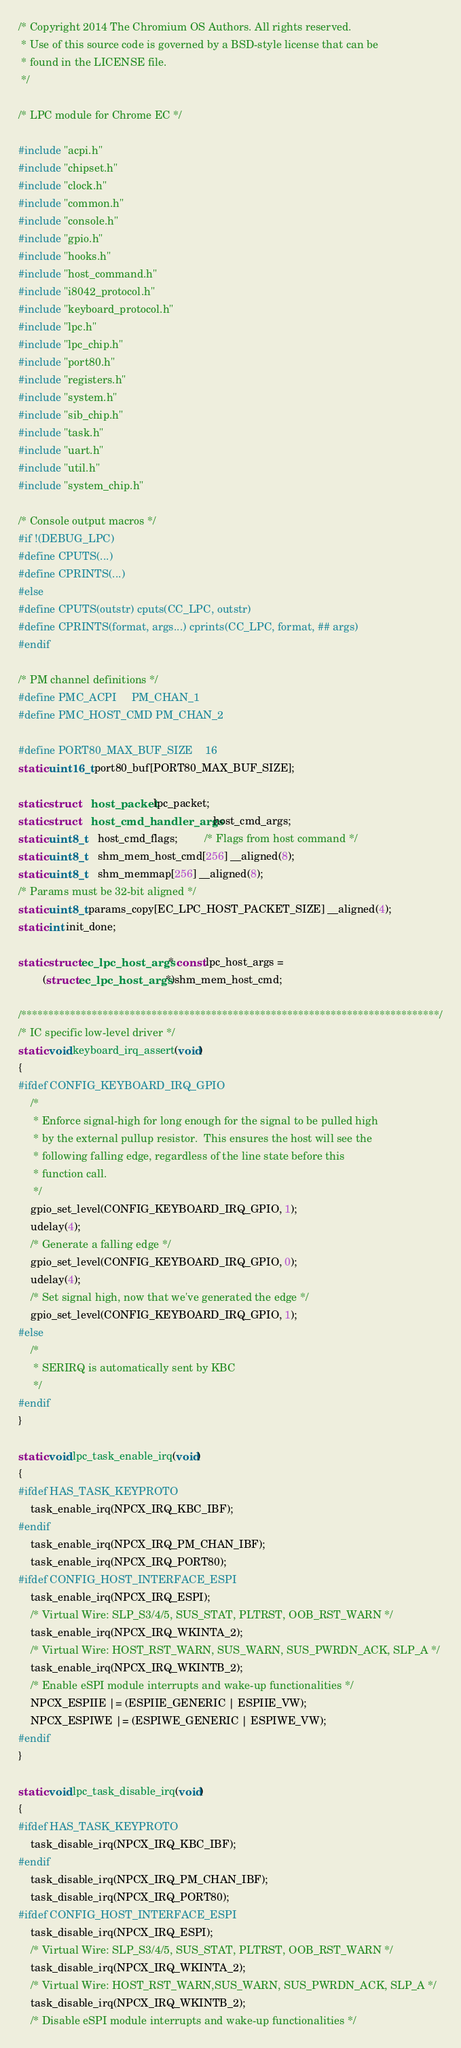Convert code to text. <code><loc_0><loc_0><loc_500><loc_500><_C_>/* Copyright 2014 The Chromium OS Authors. All rights reserved.
 * Use of this source code is governed by a BSD-style license that can be
 * found in the LICENSE file.
 */

/* LPC module for Chrome EC */

#include "acpi.h"
#include "chipset.h"
#include "clock.h"
#include "common.h"
#include "console.h"
#include "gpio.h"
#include "hooks.h"
#include "host_command.h"
#include "i8042_protocol.h"
#include "keyboard_protocol.h"
#include "lpc.h"
#include "lpc_chip.h"
#include "port80.h"
#include "registers.h"
#include "system.h"
#include "sib_chip.h"
#include "task.h"
#include "uart.h"
#include "util.h"
#include "system_chip.h"

/* Console output macros */
#if !(DEBUG_LPC)
#define CPUTS(...)
#define CPRINTS(...)
#else
#define CPUTS(outstr) cputs(CC_LPC, outstr)
#define CPRINTS(format, args...) cprints(CC_LPC, format, ## args)
#endif

/* PM channel definitions */
#define PMC_ACPI     PM_CHAN_1
#define PMC_HOST_CMD PM_CHAN_2

#define PORT80_MAX_BUF_SIZE    16
static uint16_t port80_buf[PORT80_MAX_BUF_SIZE];

static struct	host_packet lpc_packet;
static struct	host_cmd_handler_args host_cmd_args;
static uint8_t	host_cmd_flags;         /* Flags from host command */
static uint8_t	shm_mem_host_cmd[256] __aligned(8);
static uint8_t	shm_memmap[256] __aligned(8);
/* Params must be 32-bit aligned */
static uint8_t params_copy[EC_LPC_HOST_PACKET_SIZE] __aligned(4);
static int init_done;

static struct ec_lpc_host_args * const lpc_host_args =
		(struct ec_lpc_host_args *)shm_mem_host_cmd;

/*****************************************************************************/
/* IC specific low-level driver */
static void keyboard_irq_assert(void)
{
#ifdef CONFIG_KEYBOARD_IRQ_GPIO
	/*
	 * Enforce signal-high for long enough for the signal to be pulled high
	 * by the external pullup resistor.  This ensures the host will see the
	 * following falling edge, regardless of the line state before this
	 * function call.
	 */
	gpio_set_level(CONFIG_KEYBOARD_IRQ_GPIO, 1);
	udelay(4);
	/* Generate a falling edge */
	gpio_set_level(CONFIG_KEYBOARD_IRQ_GPIO, 0);
	udelay(4);
	/* Set signal high, now that we've generated the edge */
	gpio_set_level(CONFIG_KEYBOARD_IRQ_GPIO, 1);
#else
	/*
	 * SERIRQ is automatically sent by KBC
	 */
#endif
}

static void lpc_task_enable_irq(void)
{
#ifdef HAS_TASK_KEYPROTO
	task_enable_irq(NPCX_IRQ_KBC_IBF);
#endif
	task_enable_irq(NPCX_IRQ_PM_CHAN_IBF);
	task_enable_irq(NPCX_IRQ_PORT80);
#ifdef CONFIG_HOST_INTERFACE_ESPI
	task_enable_irq(NPCX_IRQ_ESPI);
	/* Virtual Wire: SLP_S3/4/5, SUS_STAT, PLTRST, OOB_RST_WARN */
	task_enable_irq(NPCX_IRQ_WKINTA_2);
	/* Virtual Wire: HOST_RST_WARN, SUS_WARN, SUS_PWRDN_ACK, SLP_A */
	task_enable_irq(NPCX_IRQ_WKINTB_2);
	/* Enable eSPI module interrupts and wake-up functionalities */
	NPCX_ESPIIE |= (ESPIIE_GENERIC | ESPIIE_VW);
	NPCX_ESPIWE |= (ESPIWE_GENERIC | ESPIWE_VW);
#endif
}

static void lpc_task_disable_irq(void)
{
#ifdef HAS_TASK_KEYPROTO
	task_disable_irq(NPCX_IRQ_KBC_IBF);
#endif
	task_disable_irq(NPCX_IRQ_PM_CHAN_IBF);
	task_disable_irq(NPCX_IRQ_PORT80);
#ifdef CONFIG_HOST_INTERFACE_ESPI
	task_disable_irq(NPCX_IRQ_ESPI);
	/* Virtual Wire: SLP_S3/4/5, SUS_STAT, PLTRST, OOB_RST_WARN */
	task_disable_irq(NPCX_IRQ_WKINTA_2);
	/* Virtual Wire: HOST_RST_WARN,SUS_WARN, SUS_PWRDN_ACK, SLP_A */
	task_disable_irq(NPCX_IRQ_WKINTB_2);
	/* Disable eSPI module interrupts and wake-up functionalities */</code> 